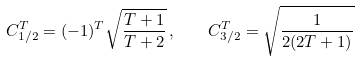Convert formula to latex. <formula><loc_0><loc_0><loc_500><loc_500>C _ { 1 / 2 } ^ { T } = ( - 1 ) ^ { T } \sqrt { \frac { T + 1 } { T + 2 } } \, , \quad C _ { 3 / 2 } ^ { T } = \sqrt { \frac { 1 } { 2 ( 2 T + 1 ) } }</formula> 